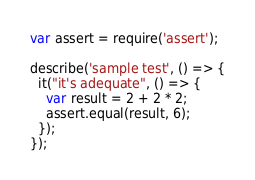Convert code to text. <code><loc_0><loc_0><loc_500><loc_500><_JavaScript_>var assert = require('assert');

describe('sample test', () => {
  it("it's adequate", () => {
    var result = 2 + 2 * 2;
    assert.equal(result, 6);
  });
});
</code> 